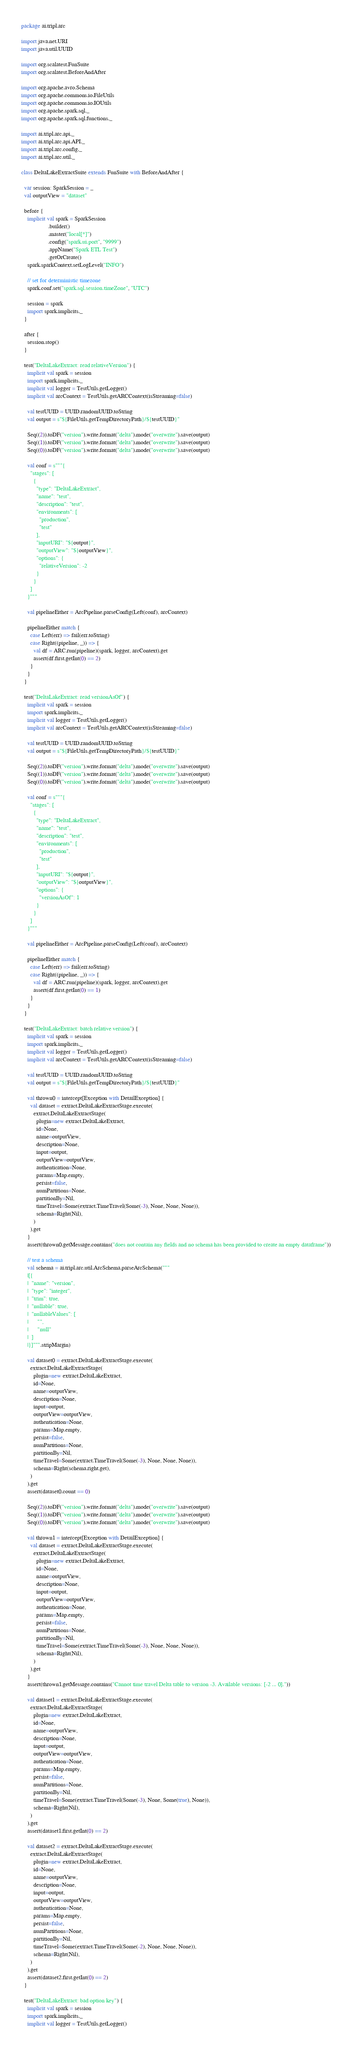Convert code to text. <code><loc_0><loc_0><loc_500><loc_500><_Scala_>package ai.tripl.arc

import java.net.URI
import java.util.UUID

import org.scalatest.FunSuite
import org.scalatest.BeforeAndAfter

import org.apache.avro.Schema
import org.apache.commons.io.FileUtils
import org.apache.commons.io.IOUtils
import org.apache.spark.sql._
import org.apache.spark.sql.functions._

import ai.tripl.arc.api._
import ai.tripl.arc.api.API._
import ai.tripl.arc.config._
import ai.tripl.arc.util._

class DeltaLakeExtractSuite extends FunSuite with BeforeAndAfter {

  var session: SparkSession = _
  val outputView = "dataset"

  before {
    implicit val spark = SparkSession
                  .builder()
                  .master("local[*]")
                  .config("spark.ui.port", "9999")
                  .appName("Spark ETL Test")
                  .getOrCreate()
    spark.sparkContext.setLogLevel("INFO")

    // set for deterministic timezone
    spark.conf.set("spark.sql.session.timeZone", "UTC")

    session = spark
    import spark.implicits._
  }

  after {
    session.stop()
  }

  test("DeltaLakeExtract: read relativeVersion") {
    implicit val spark = session
    import spark.implicits._
    implicit val logger = TestUtils.getLogger()
    implicit val arcContext = TestUtils.getARCContext(isStreaming=false)

    val testUUID = UUID.randomUUID.toString
    val output = s"${FileUtils.getTempDirectoryPath}/${testUUID}"

    Seq((2)).toDF("version").write.format("delta").mode("overwrite").save(output)
    Seq((1)).toDF("version").write.format("delta").mode("overwrite").save(output)
    Seq((0)).toDF("version").write.format("delta").mode("overwrite").save(output)

    val conf = s"""{
      "stages": [
        {
          "type": "DeltaLakeExtract",
          "name": "test",
          "description": "test",
          "environments": [
            "production",
            "test"
          ],
          "inputURI": "${output}",
          "outputView": "${outputView}",
          "options": {
            "relativeVersion": -2
          }
        }
      ]
    }"""

    val pipelineEither = ArcPipeline.parseConfig(Left(conf), arcContext)

    pipelineEither match {
      case Left(err) => fail(err.toString)
      case Right((pipeline, _)) => {
        val df = ARC.run(pipeline)(spark, logger, arcContext).get
        assert(df.first.getInt(0) == 2)
      }
    }
  }

  test("DeltaLakeExtract: read versionAsOf") {
    implicit val spark = session
    import spark.implicits._
    implicit val logger = TestUtils.getLogger()
    implicit val arcContext = TestUtils.getARCContext(isStreaming=false)

    val testUUID = UUID.randomUUID.toString
    val output = s"${FileUtils.getTempDirectoryPath}/${testUUID}"

    Seq((2)).toDF("version").write.format("delta").mode("overwrite").save(output)
    Seq((1)).toDF("version").write.format("delta").mode("overwrite").save(output)
    Seq((0)).toDF("version").write.format("delta").mode("overwrite").save(output)

    val conf = s"""{
      "stages": [
        {
          "type": "DeltaLakeExtract",
          "name": "test",
          "description": "test",
          "environments": [
            "production",
            "test"
          ],
          "inputURI": "${output}",
          "outputView": "${outputView}",
          "options": {
            "versionAsOf": 1
          }
        }
      ]
    }"""

    val pipelineEither = ArcPipeline.parseConfig(Left(conf), arcContext)

    pipelineEither match {
      case Left(err) => fail(err.toString)
      case Right((pipeline, _)) => {
        val df = ARC.run(pipeline)(spark, logger, arcContext).get
        assert(df.first.getInt(0) == 1)
      }
    }
  }

  test("DeltaLakeExtract: batch relative version") {
    implicit val spark = session
    import spark.implicits._
    implicit val logger = TestUtils.getLogger()
    implicit val arcContext = TestUtils.getARCContext(isStreaming=false)

    val testUUID = UUID.randomUUID.toString
    val output = s"${FileUtils.getTempDirectoryPath}/${testUUID}"

    val thrown0 = intercept[Exception with DetailException] {
      val dataset = extract.DeltaLakeExtractStage.execute(
        extract.DeltaLakeExtractStage(
          plugin=new extract.DeltaLakeExtract,
          id=None,
          name=outputView,
          description=None,
          input=output,
          outputView=outputView,
          authentication=None,
          params=Map.empty,
          persist=false,
          numPartitions=None,
          partitionBy=Nil,
          timeTravel=Some(extract.TimeTravel(Some(-3), None, None, None)),
          schema=Right(Nil),
        )
      ).get
    }
    assert(thrown0.getMessage.contains("does not contain any fields and no schema has been provided to create an empty dataframe"))

    // test a schema
    val schema = ai.tripl.arc.util.ArcSchema.parseArcSchema("""
    |[{
    |  "name": "version",
    |  "type": "integer",
    |  "trim": true,
    |  "nullable": true,
    |  "nullableValues": [
    |      "",
    |      "null"
    |  ]
    |}]""".stripMargin)

    val dataset0 = extract.DeltaLakeExtractStage.execute(
      extract.DeltaLakeExtractStage(
        plugin=new extract.DeltaLakeExtract,
        id=None,
        name=outputView,
        description=None,
        input=output,
        outputView=outputView,
        authentication=None,
        params=Map.empty,
        persist=false,
        numPartitions=None,
        partitionBy=Nil,
        timeTravel=Some(extract.TimeTravel(Some(-3), None, None, None)),
        schema=Right(schema.right.get),
      )
    ).get
    assert(dataset0.count == 0)

    Seq((2)).toDF("version").write.format("delta").mode("overwrite").save(output)
    Seq((1)).toDF("version").write.format("delta").mode("overwrite").save(output)
    Seq((0)).toDF("version").write.format("delta").mode("overwrite").save(output)

    val thrown1 = intercept[Exception with DetailException] {
      val dataset = extract.DeltaLakeExtractStage.execute(
        extract.DeltaLakeExtractStage(
          plugin=new extract.DeltaLakeExtract,
          id=None,
          name=outputView,
          description=None,
          input=output,
          outputView=outputView,
          authentication=None,
          params=Map.empty,
          persist=false,
          numPartitions=None,
          partitionBy=Nil,
          timeTravel=Some(extract.TimeTravel(Some(-3), None, None, None)),
          schema=Right(Nil),
        )
      ).get
    }
    assert(thrown1.getMessage.contains("Cannot time travel Delta table to version -3. Available versions: [-2 ... 0]."))

    val dataset1 = extract.DeltaLakeExtractStage.execute(
      extract.DeltaLakeExtractStage(
        plugin=new extract.DeltaLakeExtract,
        id=None,
        name=outputView,
        description=None,
        input=output,
        outputView=outputView,
        authentication=None,
        params=Map.empty,
        persist=false,
        numPartitions=None,
        partitionBy=Nil,
        timeTravel=Some(extract.TimeTravel(Some(-3), None, Some(true), None)),
        schema=Right(Nil),
      )
    ).get
    assert(dataset1.first.getInt(0) == 2)

    val dataset2 = extract.DeltaLakeExtractStage.execute(
      extract.DeltaLakeExtractStage(
        plugin=new extract.DeltaLakeExtract,
        id=None,
        name=outputView,
        description=None,
        input=output,
        outputView=outputView,
        authentication=None,
        params=Map.empty,
        persist=false,
        numPartitions=None,
        partitionBy=Nil,
        timeTravel=Some(extract.TimeTravel(Some(-2), None, None, None)),
        schema=Right(Nil),
      )
    ).get
    assert(dataset2.first.getInt(0) == 2)
  }

  test("DeltaLakeExtract: bad option key") {
    implicit val spark = session
    import spark.implicits._
    implicit val logger = TestUtils.getLogger()</code> 